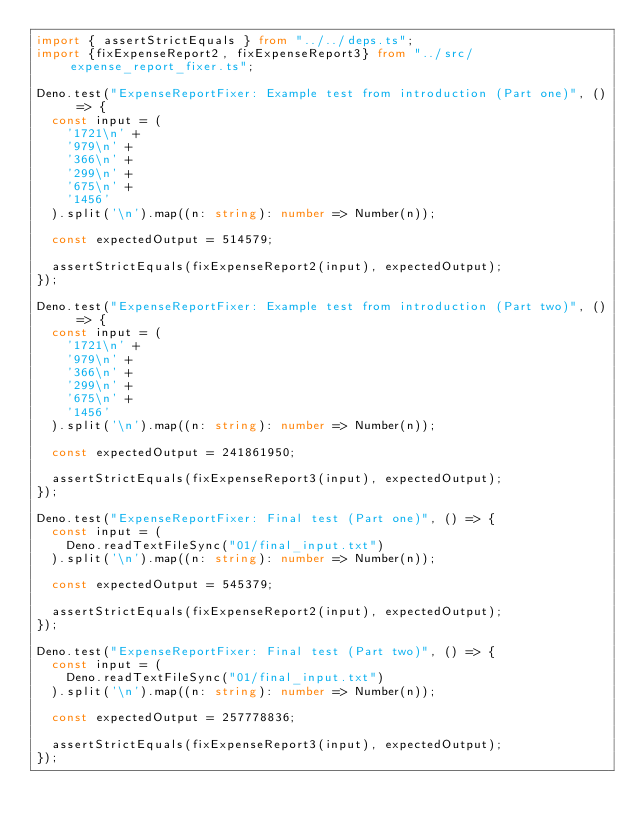Convert code to text. <code><loc_0><loc_0><loc_500><loc_500><_TypeScript_>import { assertStrictEquals } from "../../deps.ts";
import {fixExpenseReport2, fixExpenseReport3} from "../src/expense_report_fixer.ts";

Deno.test("ExpenseReportFixer: Example test from introduction (Part one)", () => {
  const input = (
    '1721\n' +
    '979\n' +
    '366\n' +
    '299\n' +
    '675\n' +
    '1456'
  ).split('\n').map((n: string): number => Number(n));

  const expectedOutput = 514579;

  assertStrictEquals(fixExpenseReport2(input), expectedOutput);
});

Deno.test("ExpenseReportFixer: Example test from introduction (Part two)", () => {
  const input = (
    '1721\n' +
    '979\n' +
    '366\n' +
    '299\n' +
    '675\n' +
    '1456'
  ).split('\n').map((n: string): number => Number(n));

  const expectedOutput = 241861950;

  assertStrictEquals(fixExpenseReport3(input), expectedOutput);
});

Deno.test("ExpenseReportFixer: Final test (Part one)", () => {
  const input = (
    Deno.readTextFileSync("01/final_input.txt")
  ).split('\n').map((n: string): number => Number(n));

  const expectedOutput = 545379;

  assertStrictEquals(fixExpenseReport2(input), expectedOutput);
});

Deno.test("ExpenseReportFixer: Final test (Part two)", () => {
  const input = (
    Deno.readTextFileSync("01/final_input.txt")
  ).split('\n').map((n: string): number => Number(n));

  const expectedOutput = 257778836;

  assertStrictEquals(fixExpenseReport3(input), expectedOutput);
});
</code> 